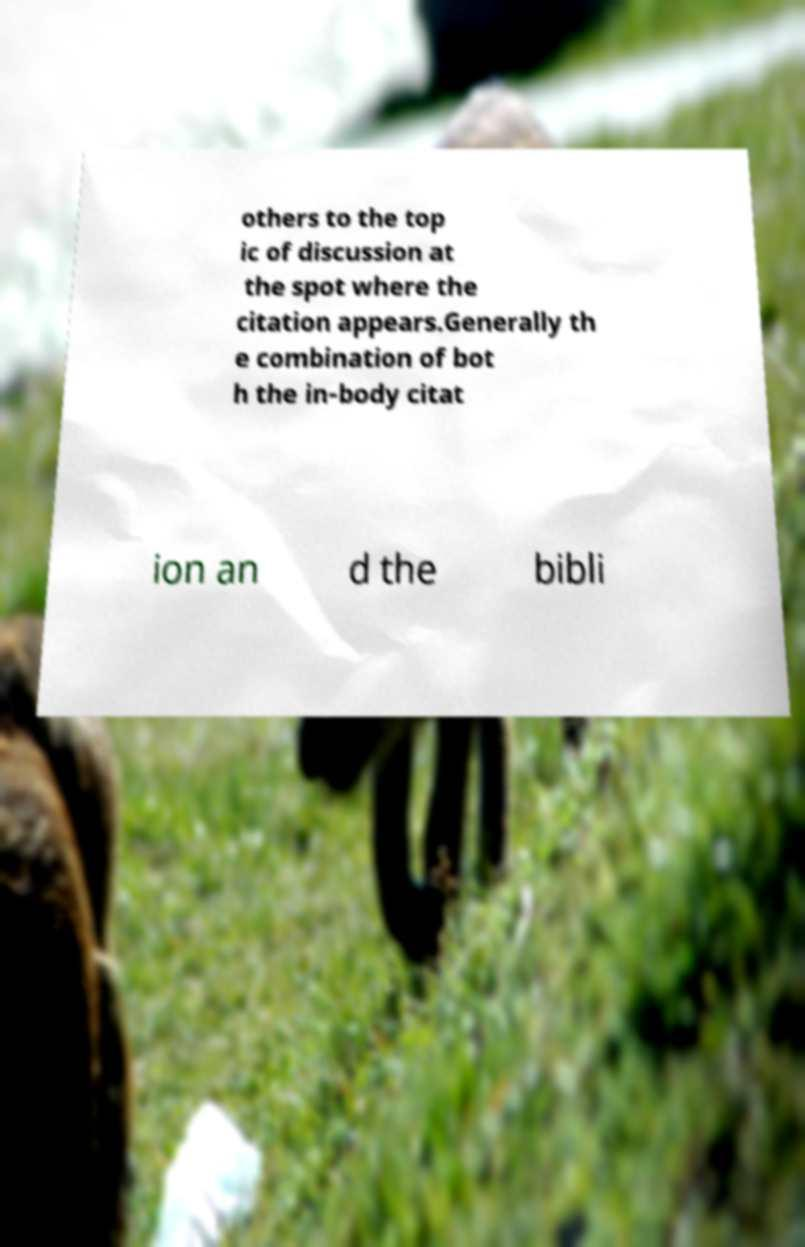Can you read and provide the text displayed in the image?This photo seems to have some interesting text. Can you extract and type it out for me? others to the top ic of discussion at the spot where the citation appears.Generally th e combination of bot h the in-body citat ion an d the bibli 